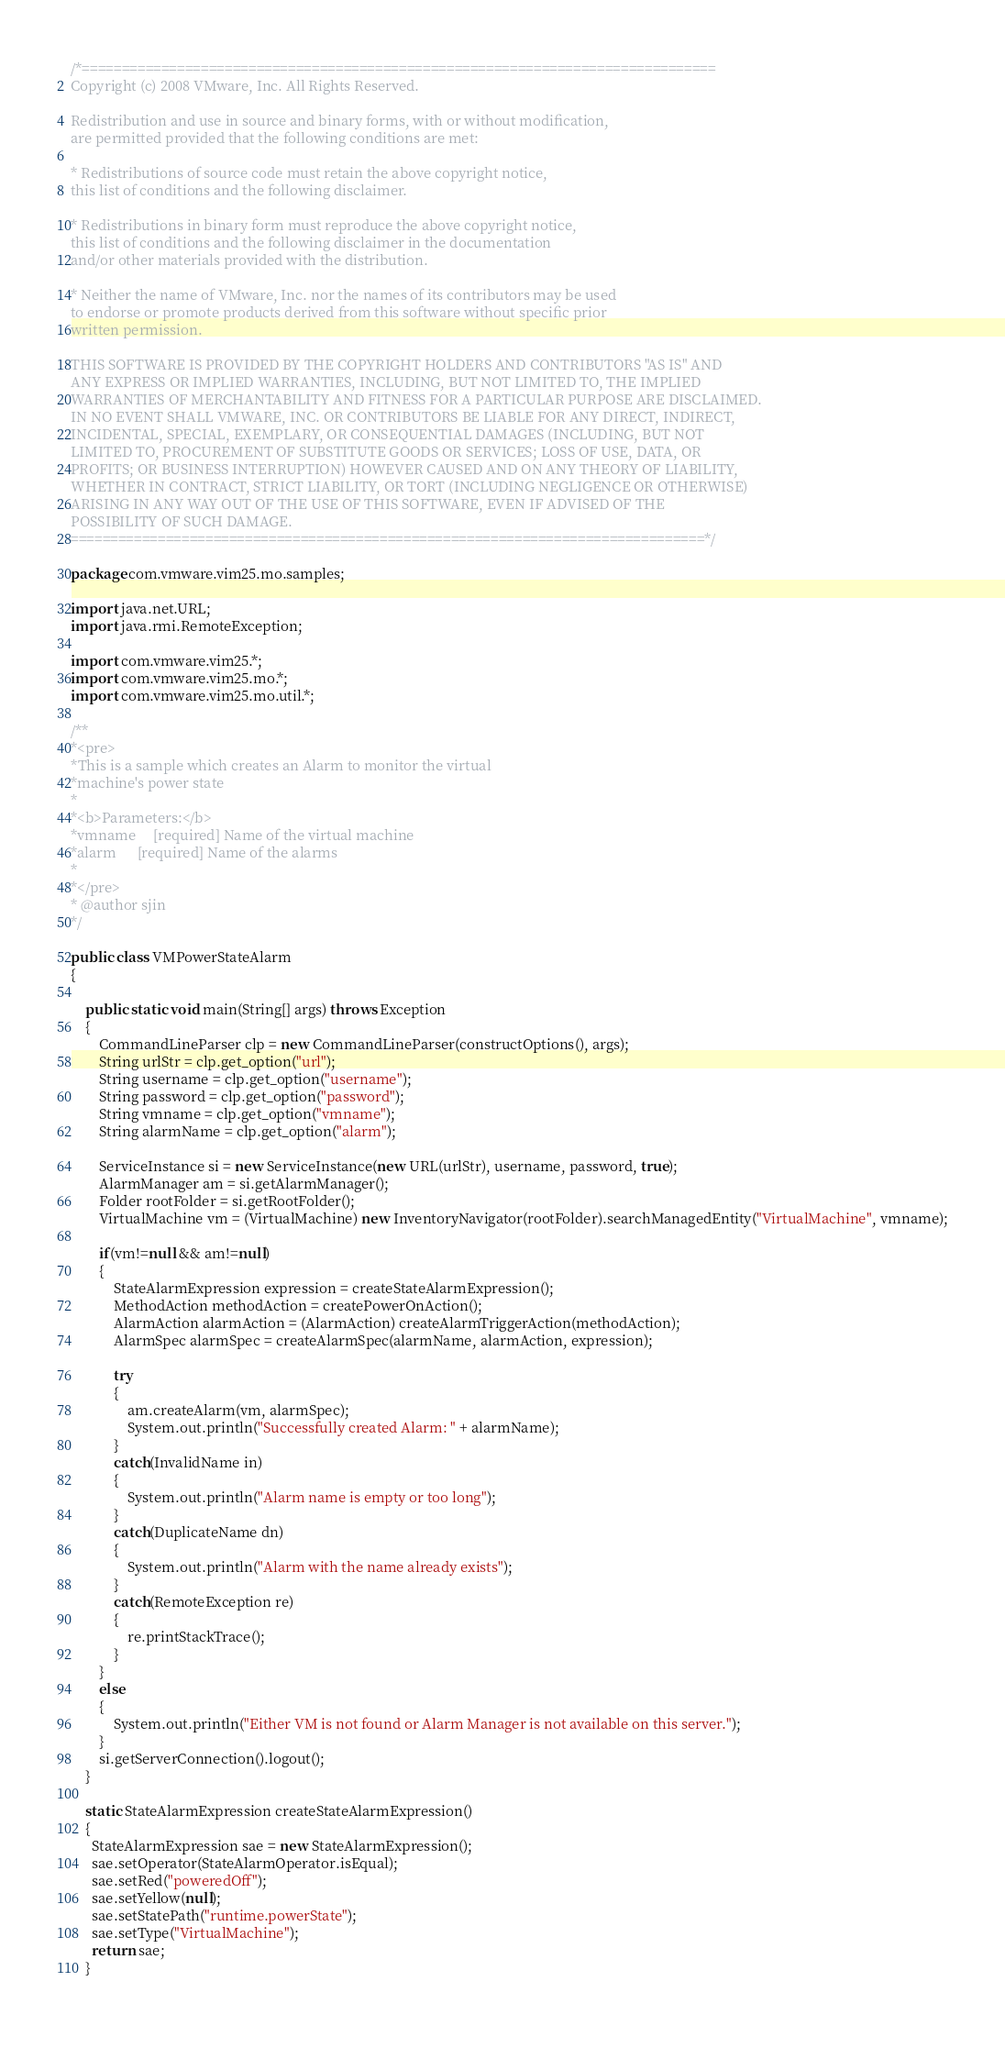<code> <loc_0><loc_0><loc_500><loc_500><_Java_>/*================================================================================
Copyright (c) 2008 VMware, Inc. All Rights Reserved.

Redistribution and use in source and binary forms, with or without modification, 
are permitted provided that the following conditions are met:

* Redistributions of source code must retain the above copyright notice, 
this list of conditions and the following disclaimer.

* Redistributions in binary form must reproduce the above copyright notice, 
this list of conditions and the following disclaimer in the documentation 
and/or other materials provided with the distribution.

* Neither the name of VMware, Inc. nor the names of its contributors may be used
to endorse or promote products derived from this software without specific prior 
written permission.

THIS SOFTWARE IS PROVIDED BY THE COPYRIGHT HOLDERS AND CONTRIBUTORS "AS IS" AND 
ANY EXPRESS OR IMPLIED WARRANTIES, INCLUDING, BUT NOT LIMITED TO, THE IMPLIED 
WARRANTIES OF MERCHANTABILITY AND FITNESS FOR A PARTICULAR PURPOSE ARE DISCLAIMED. 
IN NO EVENT SHALL VMWARE, INC. OR CONTRIBUTORS BE LIABLE FOR ANY DIRECT, INDIRECT, 
INCIDENTAL, SPECIAL, EXEMPLARY, OR CONSEQUENTIAL DAMAGES (INCLUDING, BUT NOT 
LIMITED TO, PROCUREMENT OF SUBSTITUTE GOODS OR SERVICES; LOSS OF USE, DATA, OR 
PROFITS; OR BUSINESS INTERRUPTION) HOWEVER CAUSED AND ON ANY THEORY OF LIABILITY, 
WHETHER IN CONTRACT, STRICT LIABILITY, OR TORT (INCLUDING NEGLIGENCE OR OTHERWISE) 
ARISING IN ANY WAY OUT OF THE USE OF THIS SOFTWARE, EVEN IF ADVISED OF THE 
POSSIBILITY OF SUCH DAMAGE.
================================================================================*/

package com.vmware.vim25.mo.samples;

import java.net.URL;
import java.rmi.RemoteException;

import com.vmware.vim25.*;
import com.vmware.vim25.mo.*;
import com.vmware.vim25.mo.util.*;

/**
*<pre>
*This is a sample which creates an Alarm to monitor the virtual
*machine's power state
*
*<b>Parameters:</b>
*vmname     [required] Name of the virtual machine
*alarm      [required] Name of the alarms
*
*</pre>
* @author sjin
*/

public class VMPowerStateAlarm 
{

	public static void main(String[] args) throws Exception 
	{
	    CommandLineParser clp = new CommandLineParser(constructOptions(), args);
	   	String urlStr = clp.get_option("url");
  	    String username = clp.get_option("username");
	    String password = clp.get_option("password");
	    String vmname = clp.get_option("vmname");
	    String alarmName = clp.get_option("alarm");
	   
		ServiceInstance si = new ServiceInstance(new URL(urlStr), username, password, true);
		AlarmManager am = si.getAlarmManager();
		Folder rootFolder = si.getRootFolder();
		VirtualMachine vm = (VirtualMachine) new InventoryNavigator(rootFolder).searchManagedEntity("VirtualMachine", vmname);
		
		if(vm!=null && am!=null)
		{
			StateAlarmExpression expression = createStateAlarmExpression();
			MethodAction methodAction = createPowerOnAction();
			AlarmAction alarmAction = (AlarmAction) createAlarmTriggerAction(methodAction);
			AlarmSpec alarmSpec = createAlarmSpec(alarmName, alarmAction, expression);
			
			try
			{
				am.createAlarm(vm, alarmSpec);
				System.out.println("Successfully created Alarm: " + alarmName);
			}
			catch(InvalidName in) 
			{
				System.out.println("Alarm name is empty or too long");
			}
			catch(DuplicateName dn)
			{
				System.out.println("Alarm with the name already exists");
			}
			catch(RemoteException re)
			{
				re.printStackTrace();
			}
		}
		else 
		{
			System.out.println("Either VM is not found or Alarm Manager is not available on this server.");
		}
		si.getServerConnection().logout();
	}
	
	static StateAlarmExpression createStateAlarmExpression()
	{   
	  StateAlarmExpression sae = new StateAlarmExpression();
	  sae.setOperator(StateAlarmOperator.isEqual);
	  sae.setRed("poweredOff");
	  sae.setYellow(null);
	  sae.setStatePath("runtime.powerState");
	  sae.setType("VirtualMachine");
	  return sae;
	}
   </code> 